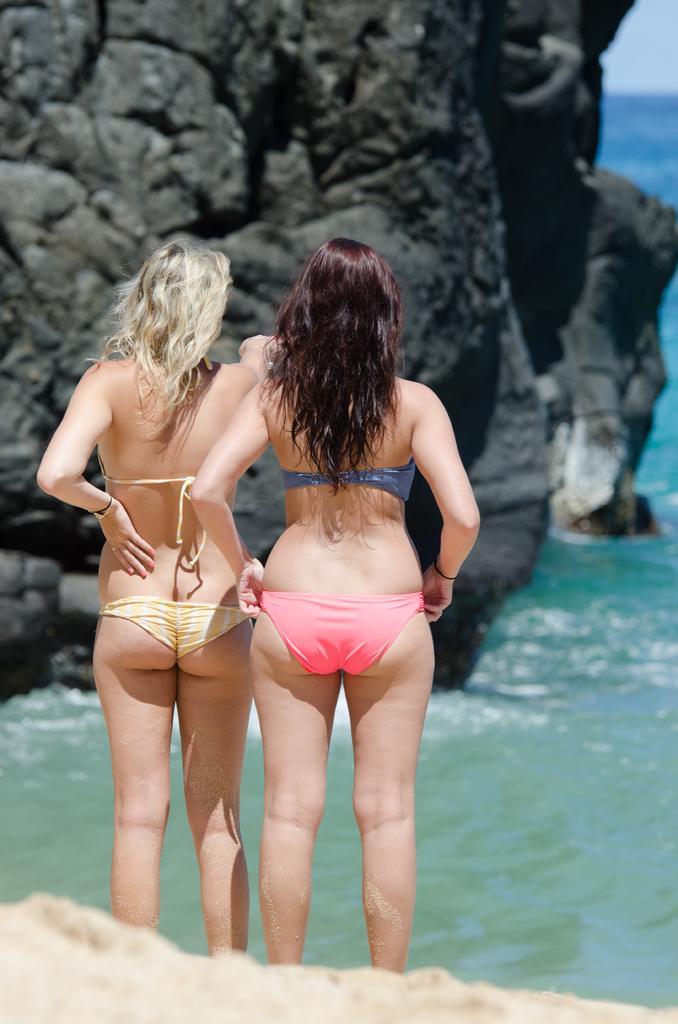Please provide a concise description of this image. In this image, we can see two women are standing. At the bottom of the image, we can see the sand. In the background, we can see the water and rocks. 